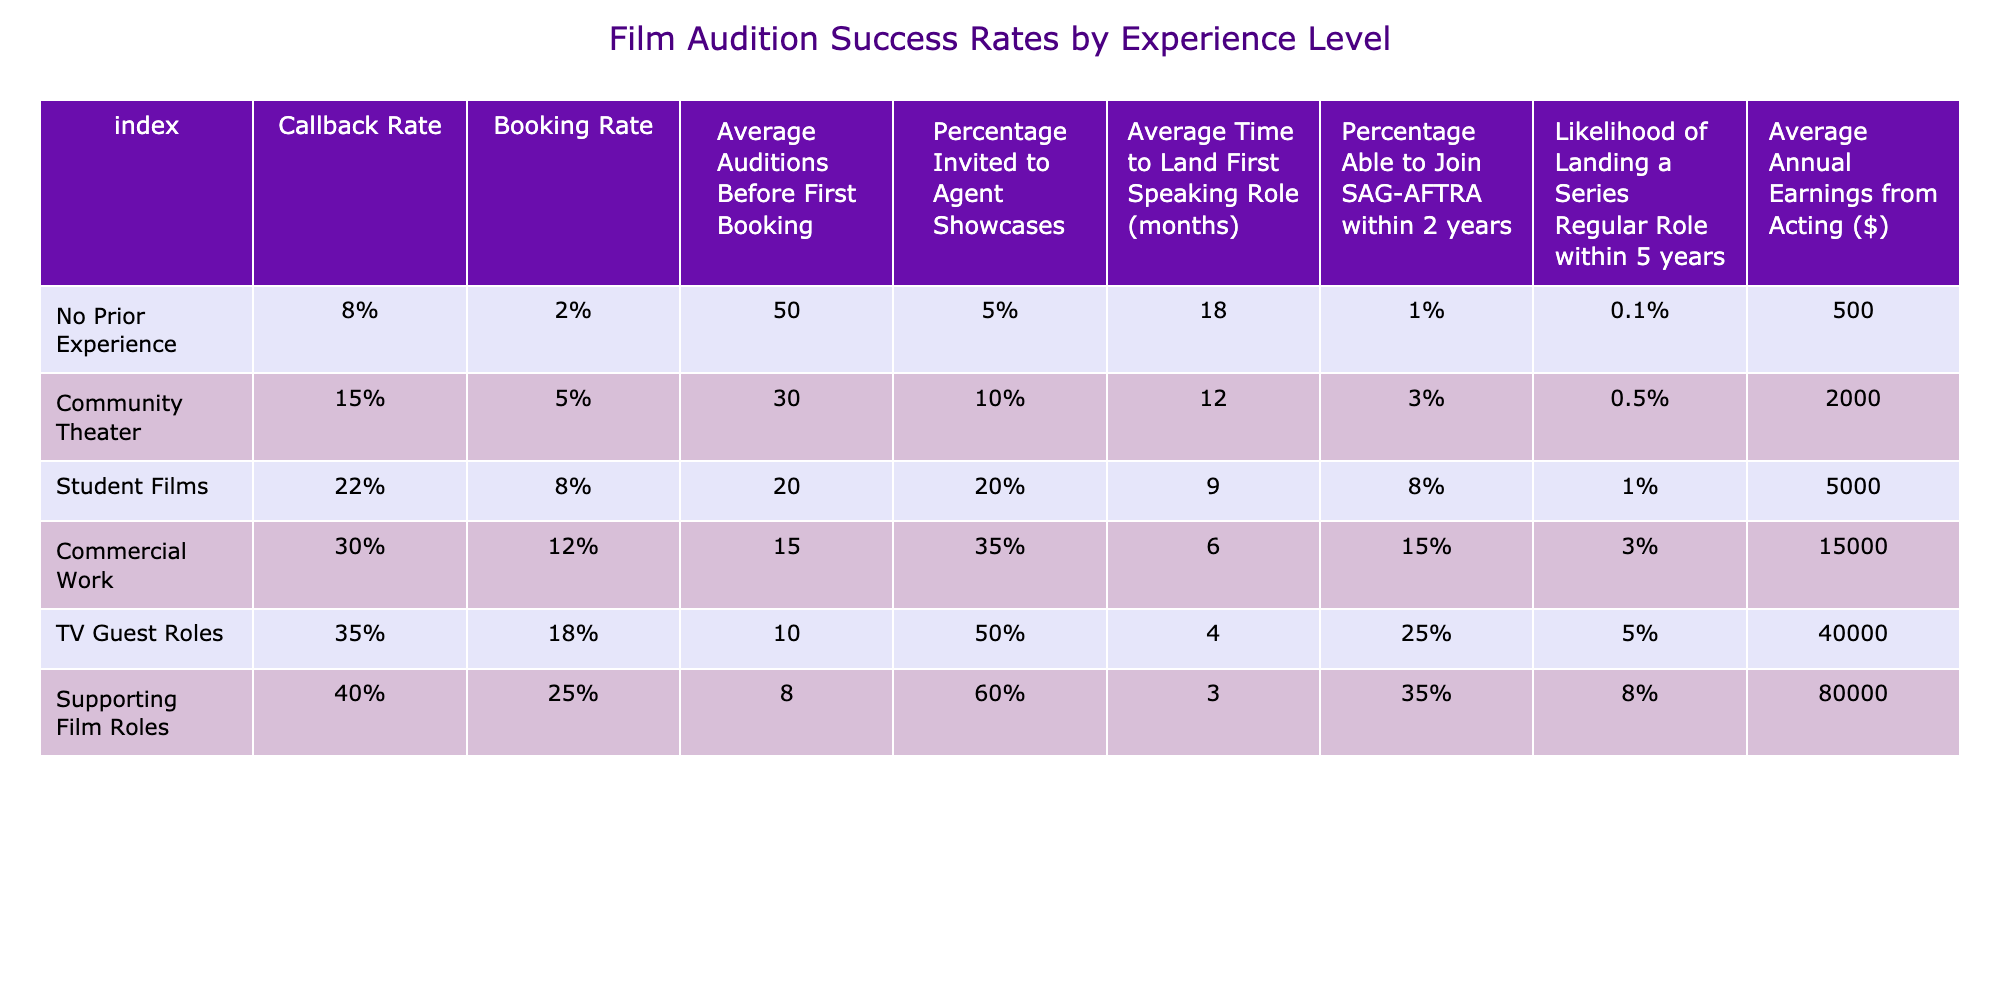What is the callback rate for individuals with community theater experience? The callback rate for individuals with community theater experience is explicitly stated in the table, which shows that it is 15%.
Answer: 15% What is the booking rate for actors who have supporting film roles? According to the table, the booking rate for actors with supporting film roles is 25%, as listed under that experience level.
Answer: 25% How many average auditions does an actor with no prior experience go through before landing their first booking? The table indicates that an actor with no prior experience goes through an average of 50 auditions before booking their first role.
Answer: 50 Is there a percentage of actors with TV guest roles that are invited to agent showcases? Yes, the table lists that 35% of actors with TV guest roles are invited to agent showcases.
Answer: Yes What is the average time taken to land the first speaking role for someone with supporting film roles? The table indicates that it takes an average of 3 months for someone with supporting film roles to land their first speaking role.
Answer: 3 months Which experience level has the highest average annual earnings from acting? The table shows that individuals with supporting film roles have the highest average annual earnings listed as $80,000.
Answer: $80,000 What is the difference in the likelihood of landing a series regular role within 5 years between actors with no prior experience and those with commercial work experience? The likelihood for no prior experience is 0.1% and for commercial work is 3%. The difference is 3% - 0.1% = 2.9%.
Answer: 2.9% What percentage of actors with community theater experience are able to join SAG-AFTRA within 2 years? The table indicates that 3% of actors with community theater experience are able to join SAG-AFTRA within 2 years.
Answer: 3% If an actor has student film experience, how many average auditions might they expect to take before their first booking? The table states that an actor with student film experience can expect to take an average of 20 auditions before their first booking.
Answer: 20 What is the percentage of individuals with no prior experience that can land a series regular role within 5 years? The table indicates that only 0.1% of individuals with no prior experience are likely to land a series regular role within 5 years.
Answer: 0.1% What is the average earnings gap between actors with TV guest roles and those with supporting film roles? The average annual earnings for TV guest roles is $40,000, and for supporting film roles, it is $80,000. The gap is $80,000 - $40,000 = $40,000.
Answer: $40,000 